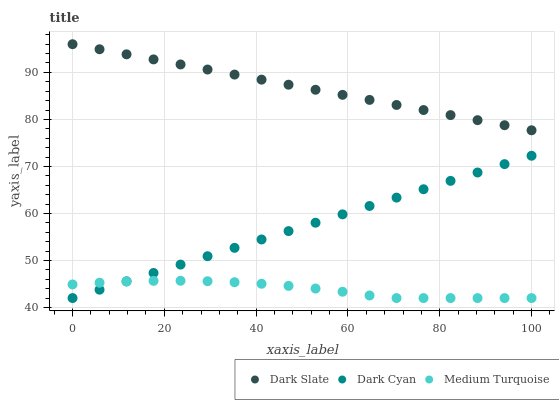Does Medium Turquoise have the minimum area under the curve?
Answer yes or no. Yes. Does Dark Slate have the maximum area under the curve?
Answer yes or no. Yes. Does Dark Slate have the minimum area under the curve?
Answer yes or no. No. Does Medium Turquoise have the maximum area under the curve?
Answer yes or no. No. Is Dark Slate the smoothest?
Answer yes or no. Yes. Is Medium Turquoise the roughest?
Answer yes or no. Yes. Is Medium Turquoise the smoothest?
Answer yes or no. No. Is Dark Slate the roughest?
Answer yes or no. No. Does Dark Cyan have the lowest value?
Answer yes or no. Yes. Does Dark Slate have the lowest value?
Answer yes or no. No. Does Dark Slate have the highest value?
Answer yes or no. Yes. Does Medium Turquoise have the highest value?
Answer yes or no. No. Is Dark Cyan less than Dark Slate?
Answer yes or no. Yes. Is Dark Slate greater than Medium Turquoise?
Answer yes or no. Yes. Does Medium Turquoise intersect Dark Cyan?
Answer yes or no. Yes. Is Medium Turquoise less than Dark Cyan?
Answer yes or no. No. Is Medium Turquoise greater than Dark Cyan?
Answer yes or no. No. Does Dark Cyan intersect Dark Slate?
Answer yes or no. No. 